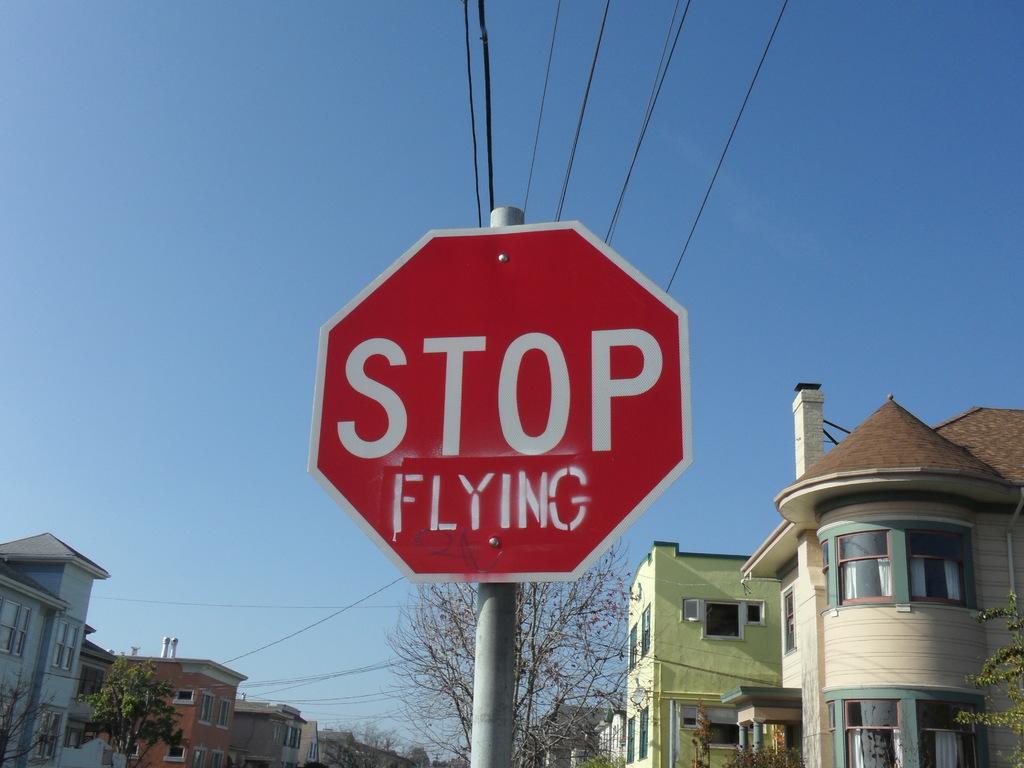Please provide a concise description of this image. Here I can see a pole to which a red color board is attached. On this I can see some text. In the background there are some buildings and trees. On the top of the image I can see the sky and wires. 